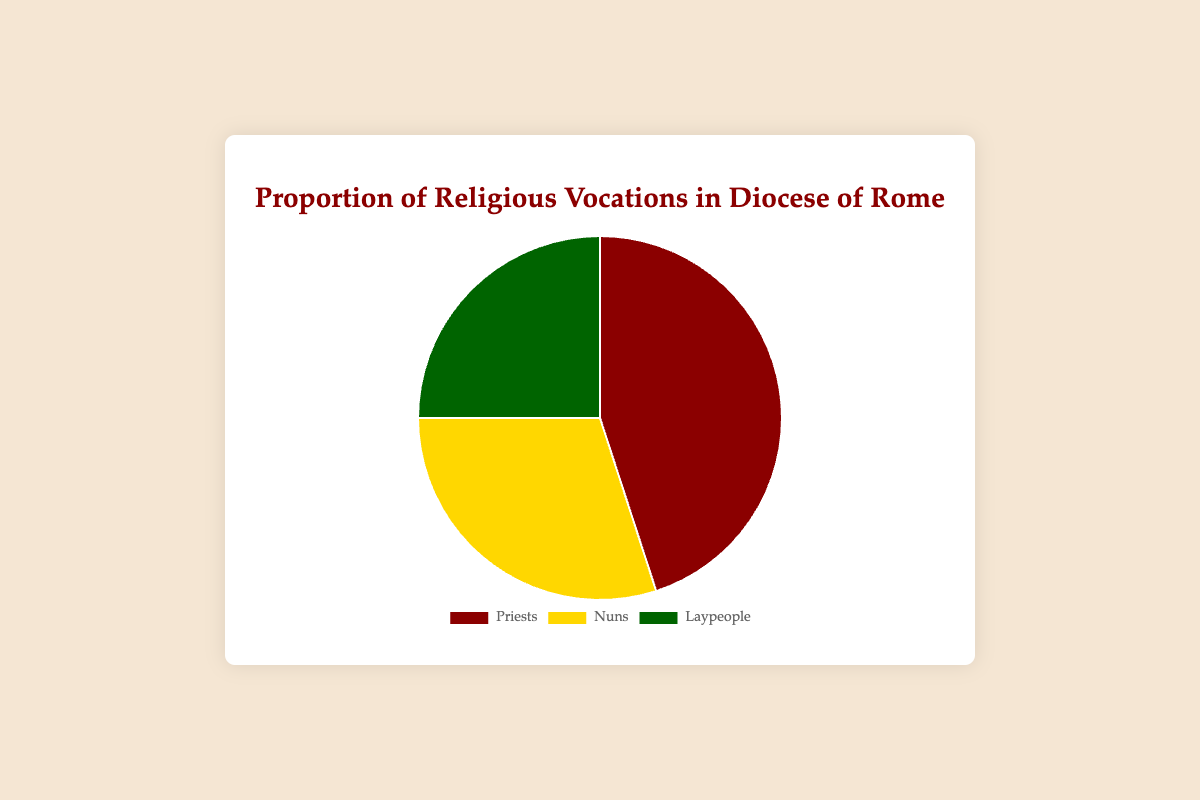What is the largest group represented in the pie chart? The pie chart shows three groups: Priests, Nuns, and Laypeople. By looking at the proportions, Priests are the largest group with 45%.
Answer: Priests What percentage of the vocations are Laypeople? The Laypeople segment of the pie chart occupies 25% of the total chart.
Answer: 25% How many percentage points more are Priests compared to Nuns? Priests occupy 45% and Nuns occupy 30%. The difference in their percentages is 45% - 30% = 15%.
Answer: 15% What is the total percentage for Priests and Nuns combined? Adding the percentages of Priests (45%) and Nuns (30%) gives 45% + 30% = 75%.
Answer: 75% Does the combined percentage of Nuns and Laypeople exceed that of Priests? Nuns and Laypeople together are 30% + 25% = 55%, which is greater than the 45% for Priests.
Answer: Yes Which group has the smallest proportion in the pie chart? Among Priests (45%), Nuns (30%), and Laypeople (25%), the smallest group is Laypeople with 25%.
Answer: Laypeople By how many percentage points do Laypeople fall short of Nuns? Nuns account for 30%, and Laypeople account for 25%. The difference is 30% - 25% = 5%.
Answer: 5% If the chart's background color is white, what are the respective colors for Priests, Nuns, and Laypeople as indicated in the chart legend? The chart legend displays Priests in red, Nuns in yellow, and Laypeople in green.
Answer: Red, Yellow, Green What proportion of the pie chart represents non-Priests? Non-Priests include Nuns and Laypeople, which together are 30% + 25% = 55%.
Answer: 55% 